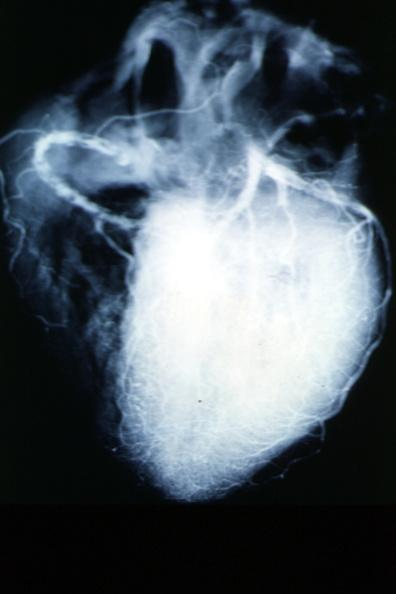where is this from?
Answer the question using a single word or phrase. Heart 